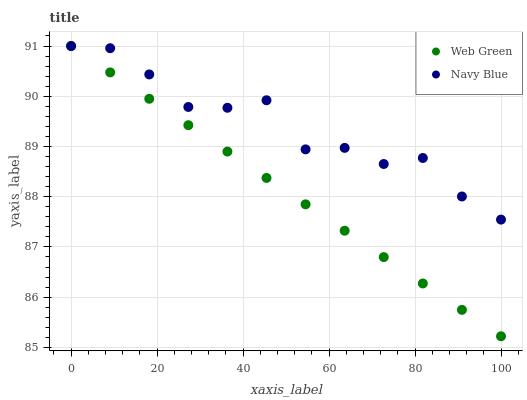Does Web Green have the minimum area under the curve?
Answer yes or no. Yes. Does Navy Blue have the maximum area under the curve?
Answer yes or no. Yes. Does Web Green have the maximum area under the curve?
Answer yes or no. No. Is Web Green the smoothest?
Answer yes or no. Yes. Is Navy Blue the roughest?
Answer yes or no. Yes. Is Web Green the roughest?
Answer yes or no. No. Does Web Green have the lowest value?
Answer yes or no. Yes. Does Web Green have the highest value?
Answer yes or no. Yes. Does Navy Blue intersect Web Green?
Answer yes or no. Yes. Is Navy Blue less than Web Green?
Answer yes or no. No. Is Navy Blue greater than Web Green?
Answer yes or no. No. 